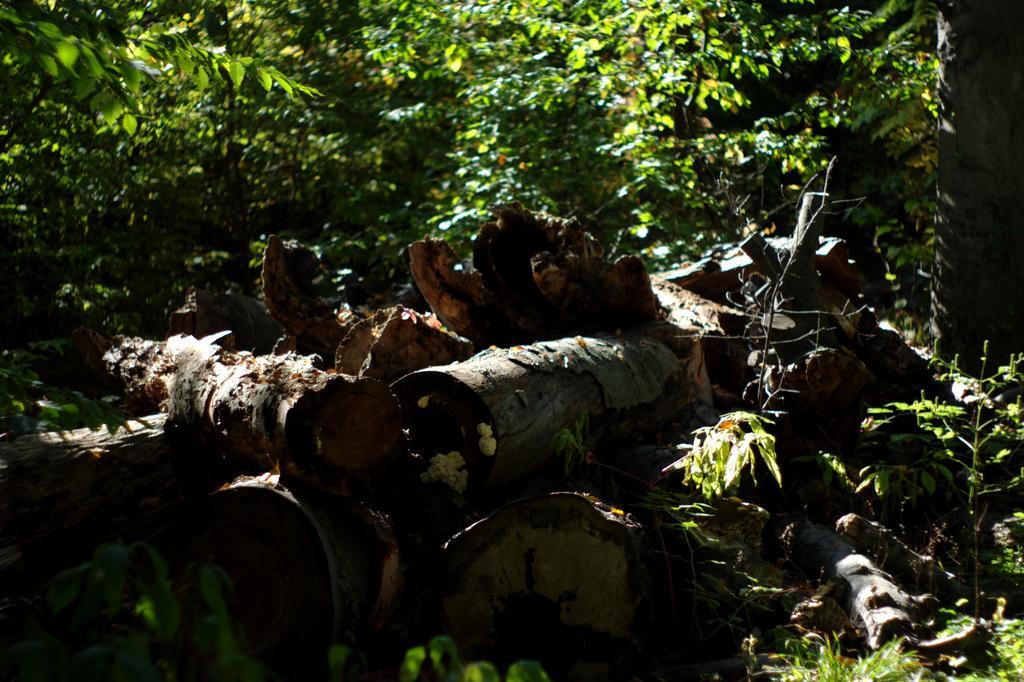In one or two sentences, can you explain what this image depicts? In this picture we can see logs and plants. In the background there are trees. 